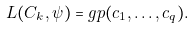Convert formula to latex. <formula><loc_0><loc_0><loc_500><loc_500>L ( C _ { k } , \psi ) = g p ( c _ { 1 } , \dots , c _ { q } ) .</formula> 